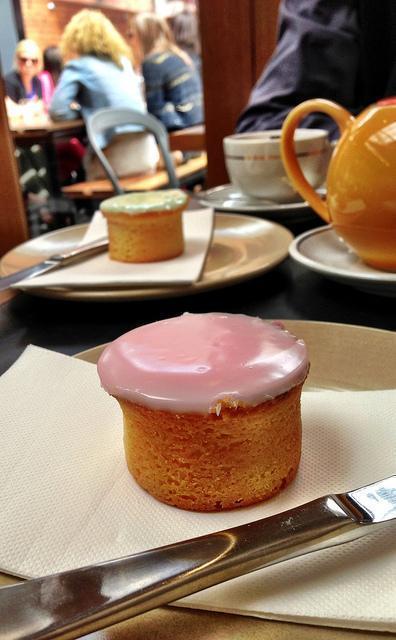What kitchen cooker is necessary for this treat's preparation?
Select the correct answer and articulate reasoning with the following format: 'Answer: answer
Rationale: rationale.'
Options: Stove top, fryer, open fire, oven. Answer: oven.
Rationale: The cooker is an oven. 